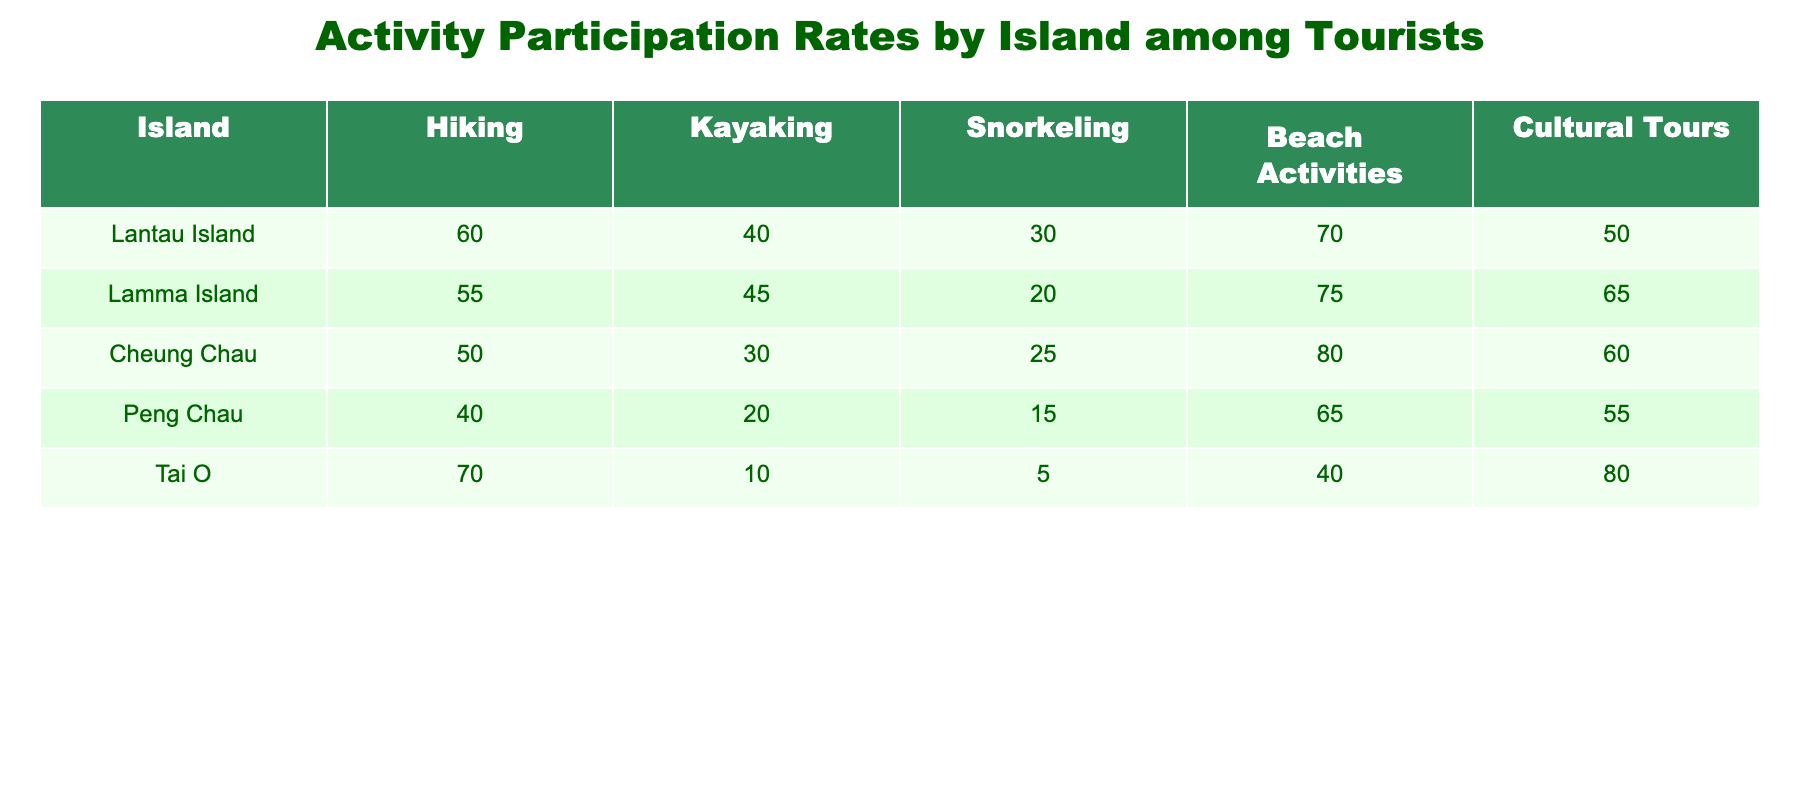What is the hiking participation rate on Lantau Island? The hiking participation rate for Lantau Island is explicitly listed in the table, which shows a value of 60.
Answer: 60 Which island has the highest participation in cultural tours? By looking at the cultural tour participation rates: Lantau Island has 50, Lamma Island has 65, Cheung Chau has 60, Peng Chau has 55, and Tai O has 80. Tai O has the highest value at 80.
Answer: Tai O What is the average snorkeling participation rate across all islands? To find the average snorkeling participation rate, sum all snorkeling rates: 30 (Lantau Island) + 20 (Lamma Island) + 25 (Cheung Chau) + 15 (Peng Chau) + 5 (Tai O) = 95. Then, divide by the number of islands (5): 95 / 5 = 19.
Answer: 19 Is the participation rate for kayaking higher on Lamma Island than on Cheung Chau? The kayaking participation rate for Lamma Island is 45, and for Cheung Chau, it is 30. Since 45 is greater than 30, the answer is yes.
Answer: Yes Which activity has the lowest participation rate on Tai O? The activity participation rates on Tai O are Hiking (70), Kayaking (10), Snorkeling (5), Beach Activities (40), and Cultural Tours (80). Snorkeling has the lowest rate at 5.
Answer: Snorkeling What is the difference in beach activities participation rates between Cheung Chau and Peng Chau? The beach activities participation rate for Cheung Chau is 80 and for Peng Chau is 65. The difference is 80 - 65 = 15.
Answer: 15 Are there any islands where kayaking participation is below 30? Looking at the kayaking rates: Lantau Island 40, Lamma Island 45, Cheung Chau 30, Peng Chau 20, and Tai O 10. Peng Chau and Tai O are below 30, so the answer is yes.
Answer: Yes What is the total participation rate for all activities on Lamma Island? The total participation rate on Lamma Island is the sum of all activity rates: 55 (Hiking) + 45 (Kayaking) + 20 (Snorkeling) + 75 (Beach Activities) + 65 (Cultural Tours) = 260.
Answer: 260 